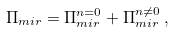Convert formula to latex. <formula><loc_0><loc_0><loc_500><loc_500>\Pi _ { m i r } = \Pi _ { m i r } ^ { n = 0 } + \Pi _ { m i r } ^ { n \neq 0 } \, ,</formula> 